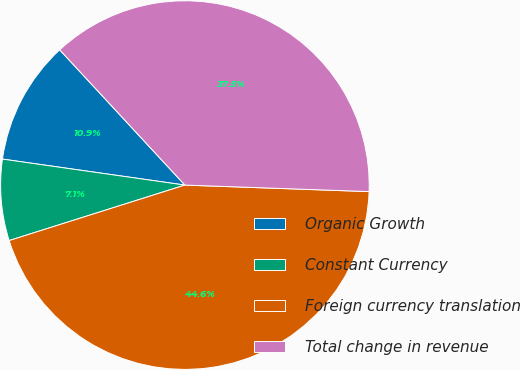<chart> <loc_0><loc_0><loc_500><loc_500><pie_chart><fcel>Organic Growth<fcel>Constant Currency<fcel>Foreign currency translation<fcel>Total change in revenue<nl><fcel>10.86%<fcel>7.12%<fcel>44.57%<fcel>37.45%<nl></chart> 